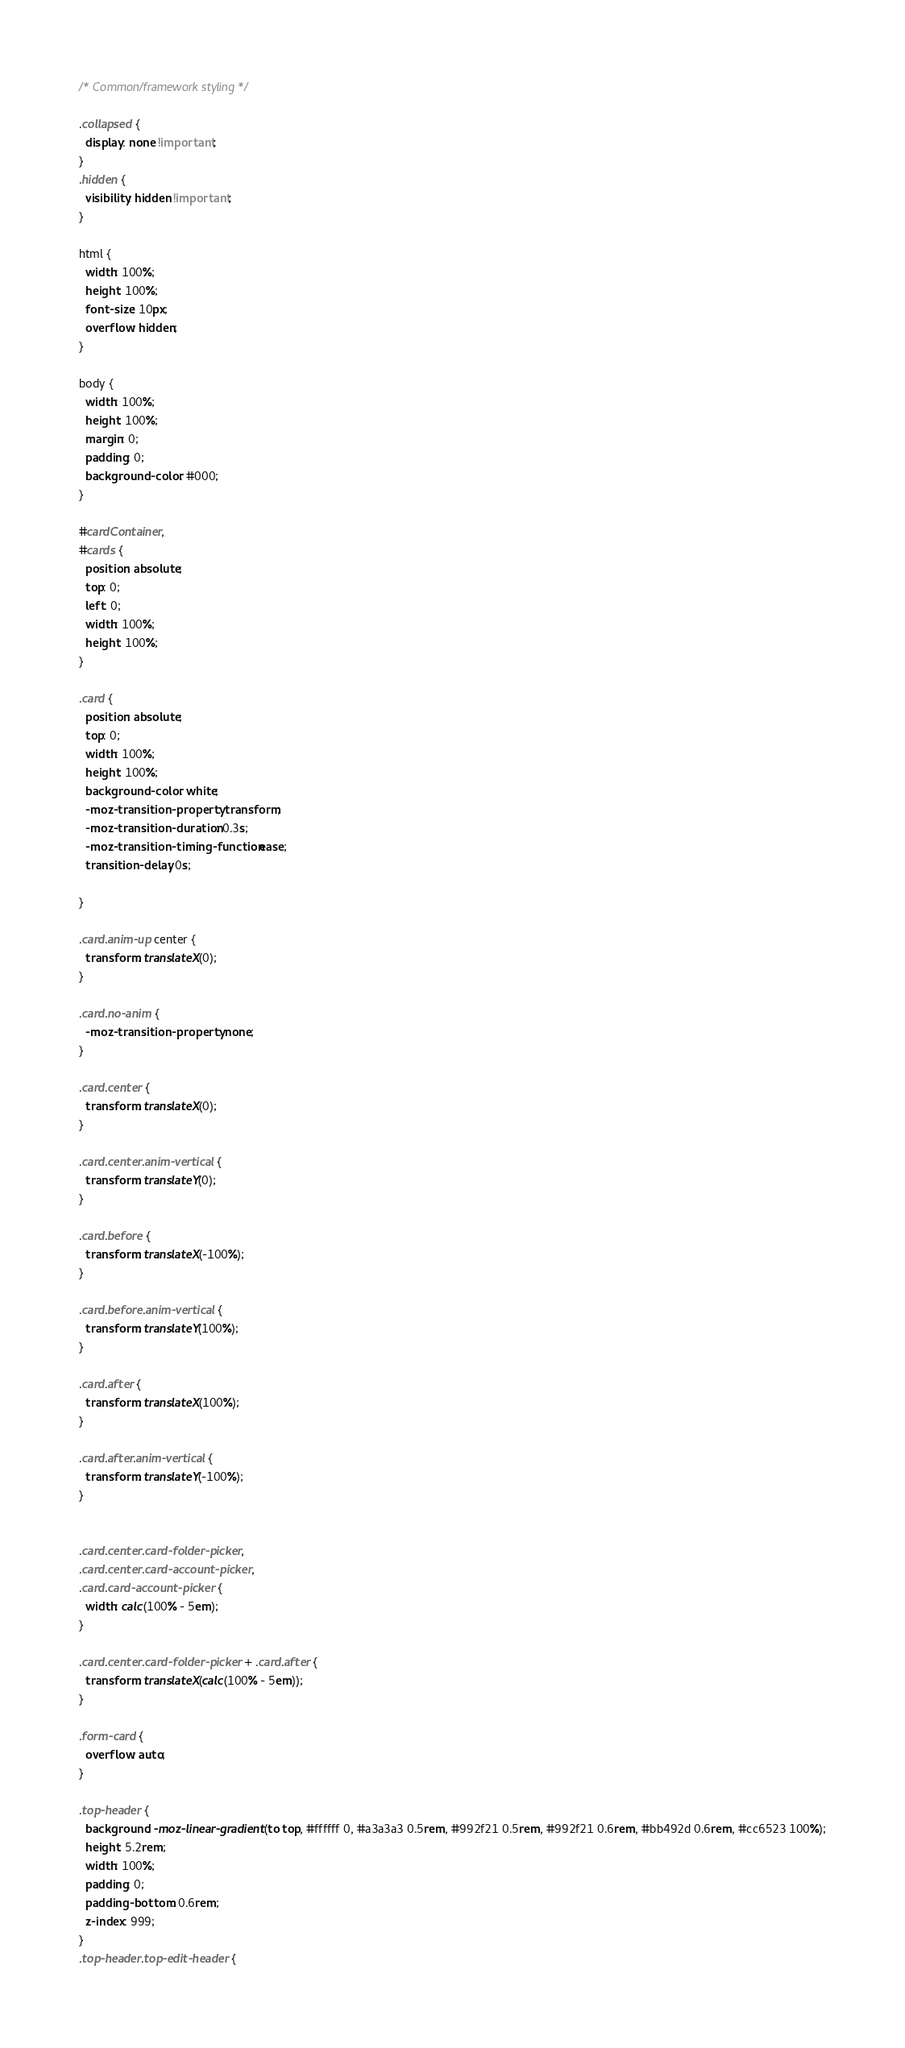<code> <loc_0><loc_0><loc_500><loc_500><_CSS_>/* Common/framework styling */

.collapsed {
  display: none !important;
}
.hidden {
  visibility: hidden !important;
}

html {
  width: 100%;
  height: 100%;
  font-size: 10px;
  overflow: hidden;
}

body {
  width: 100%;
  height: 100%;
  margin: 0;
  padding: 0;
  background-color: #000;
}

#cardContainer,
#cards {
  position: absolute;
  top: 0;
  left: 0;
  width: 100%;
  height: 100%;
}

.card {
  position: absolute;
  top: 0;
  width: 100%;
  height: 100%;
  background-color: white;
  -moz-transition-property: transform;
  -moz-transition-duration: 0.3s;
  -moz-transition-timing-function: ease;
  transition-delay: 0s;

}

.card.anim-up center {
  transform: translateX(0);
}

.card.no-anim {
  -moz-transition-property: none;
}

.card.center {
  transform: translateX(0);
}

.card.center.anim-vertical {
  transform: translateY(0);
}

.card.before {
  transform: translateX(-100%);
}

.card.before.anim-vertical {
  transform: translateY(100%);
}

.card.after {
  transform: translateX(100%);
}

.card.after.anim-vertical {
  transform: translateY(-100%);
}


.card.center.card-folder-picker,
.card.center.card-account-picker,
.card.card-account-picker {
  width: calc(100% - 5em);
}

.card.center.card-folder-picker + .card.after {
  transform: translateX(calc(100% - 5em));
}

.form-card {
  overflow: auto;
}

.top-header {
  background: -moz-linear-gradient(to top, #ffffff 0, #a3a3a3 0.5rem, #992f21 0.5rem, #992f21 0.6rem, #bb492d 0.6rem, #cc6523 100%);
  height: 5.2rem;
  width: 100%;
  padding: 0;
  padding-bottom: 0.6rem;
  z-index: 999;
}
.top-header.top-edit-header {</code> 